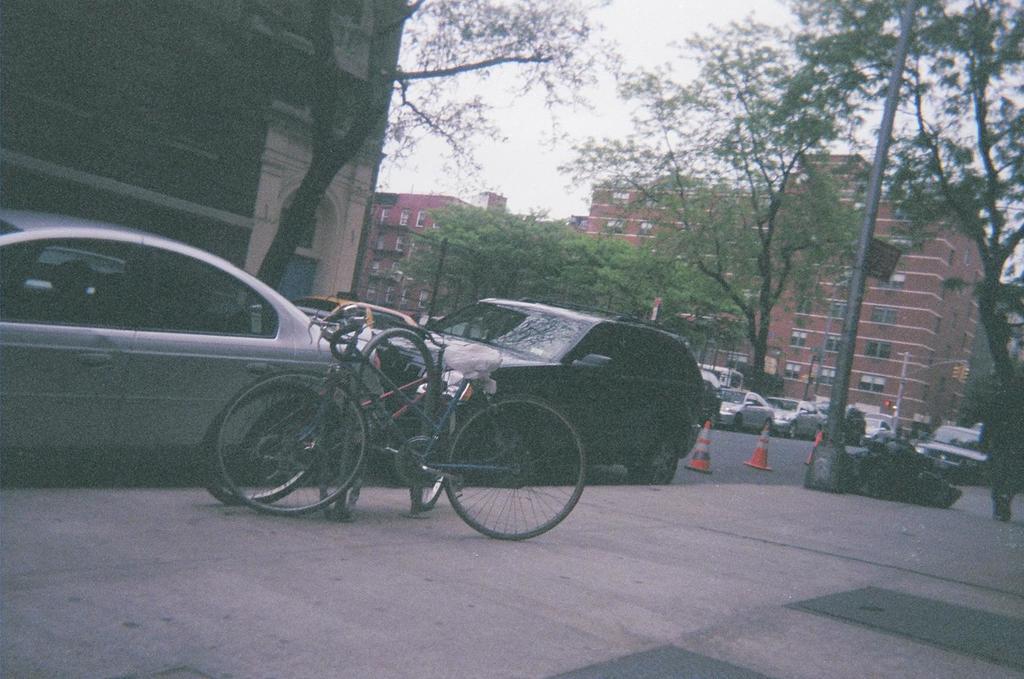Could you give a brief overview of what you see in this image? In this picture we can see some vehicles, in the background there are buildings, we can see trees in the middle, there are two bicycles, a pole and traffic cones in the front, there is the sky at the top of the picture. 